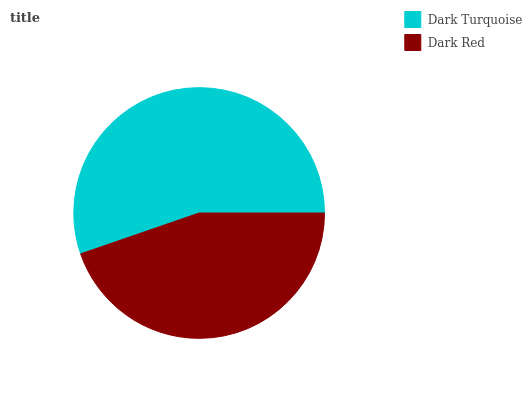Is Dark Red the minimum?
Answer yes or no. Yes. Is Dark Turquoise the maximum?
Answer yes or no. Yes. Is Dark Red the maximum?
Answer yes or no. No. Is Dark Turquoise greater than Dark Red?
Answer yes or no. Yes. Is Dark Red less than Dark Turquoise?
Answer yes or no. Yes. Is Dark Red greater than Dark Turquoise?
Answer yes or no. No. Is Dark Turquoise less than Dark Red?
Answer yes or no. No. Is Dark Turquoise the high median?
Answer yes or no. Yes. Is Dark Red the low median?
Answer yes or no. Yes. Is Dark Red the high median?
Answer yes or no. No. Is Dark Turquoise the low median?
Answer yes or no. No. 